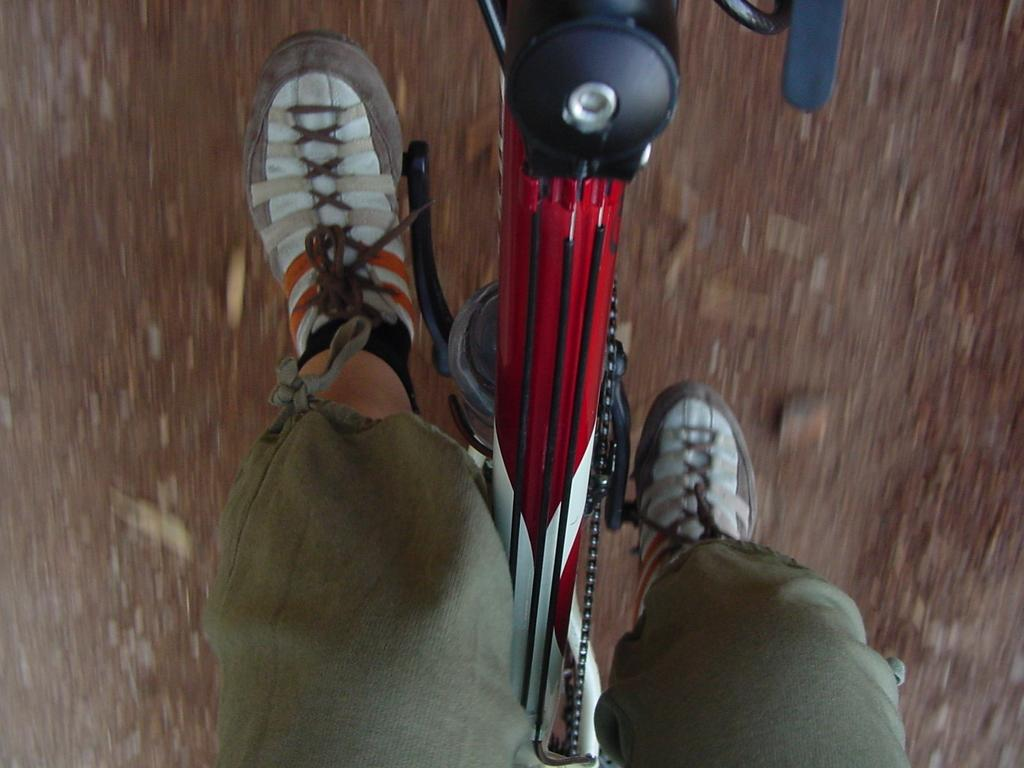What is the main subject of the image? There is a person in the image. What is the person doing in the image? The person is riding a cycle. Can you describe the background of the image? The background of the image is blurred. How many holes can be seen in the image? There are no holes visible in the image. What is the fifth element in the image? The image only has three elements mentioned in the facts: a person, a cycle, and a blurred background. There is no fifth element. 